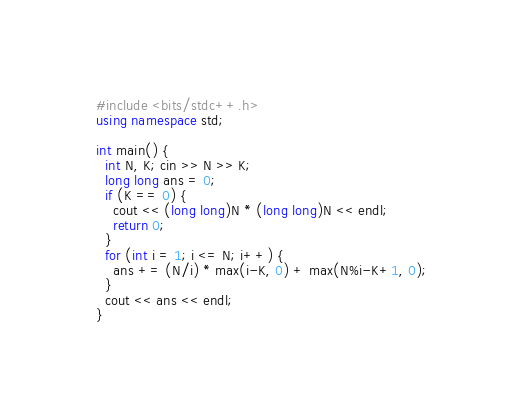<code> <loc_0><loc_0><loc_500><loc_500><_C++_>#include <bits/stdc++.h>
using namespace std;

int main() {
  int N, K; cin >> N >> K;
  long long ans = 0;
  if (K == 0) {
    cout << (long long)N * (long long)N << endl;
    return 0; 
  }
  for (int i = 1; i <= N; i++) {
    ans += (N/i) * max(i-K, 0) + max(N%i-K+1, 0);
  }
  cout << ans << endl;
}</code> 